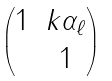<formula> <loc_0><loc_0><loc_500><loc_500>\begin{pmatrix} 1 & k \alpha _ { \ell } \\ & 1 \end{pmatrix}</formula> 